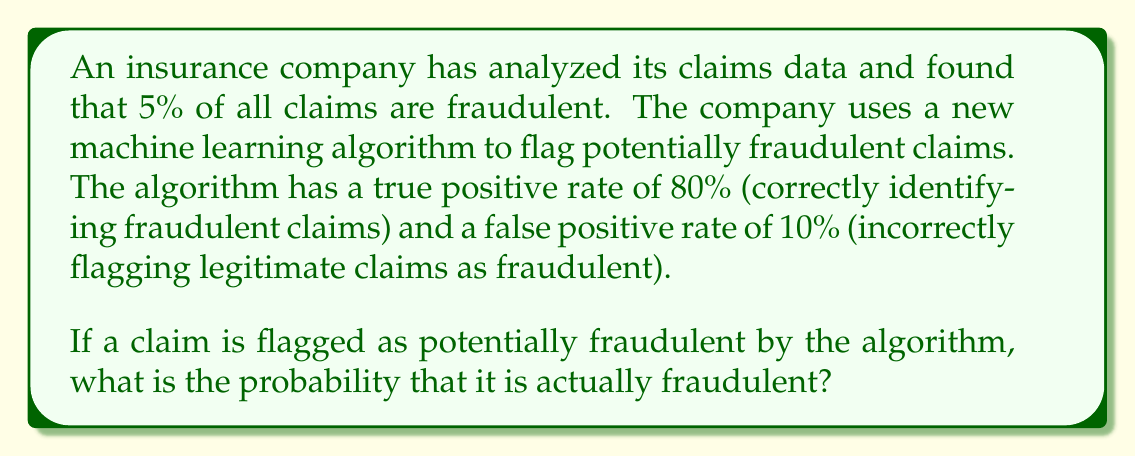Give your solution to this math problem. To solve this problem, we'll use Bayes' Theorem. Let's define our events:

$F$: The claim is fraudulent
$P$: The claim is flagged as potentially fraudulent by the algorithm

We're given:
$P(F) = 0.05$ (5% of all claims are fraudulent)
$P(P|F) = 0.80$ (80% true positive rate)
$P(P|\neg F) = 0.10$ (10% false positive rate)

We want to find $P(F|P)$, the probability that a claim is fraudulent given that it was flagged by the algorithm.

Bayes' Theorem states:

$$P(F|P) = \frac{P(P|F) \cdot P(F)}{P(P)}$$

To find $P(P)$, we use the law of total probability:

$$P(P) = P(P|F) \cdot P(F) + P(P|\neg F) \cdot P(\neg F)$$

$P(\neg F) = 1 - P(F) = 1 - 0.05 = 0.95$

Now we can calculate $P(P)$:

$$P(P) = 0.80 \cdot 0.05 + 0.10 \cdot 0.95 = 0.04 + 0.095 = 0.135$$

Plugging this back into Bayes' Theorem:

$$P(F|P) = \frac{0.80 \cdot 0.05}{0.135} = \frac{0.04}{0.135} \approx 0.2963$$
Answer: The probability that a claim flagged as potentially fraudulent is actually fraudulent is approximately 0.2963 or 29.63%. 